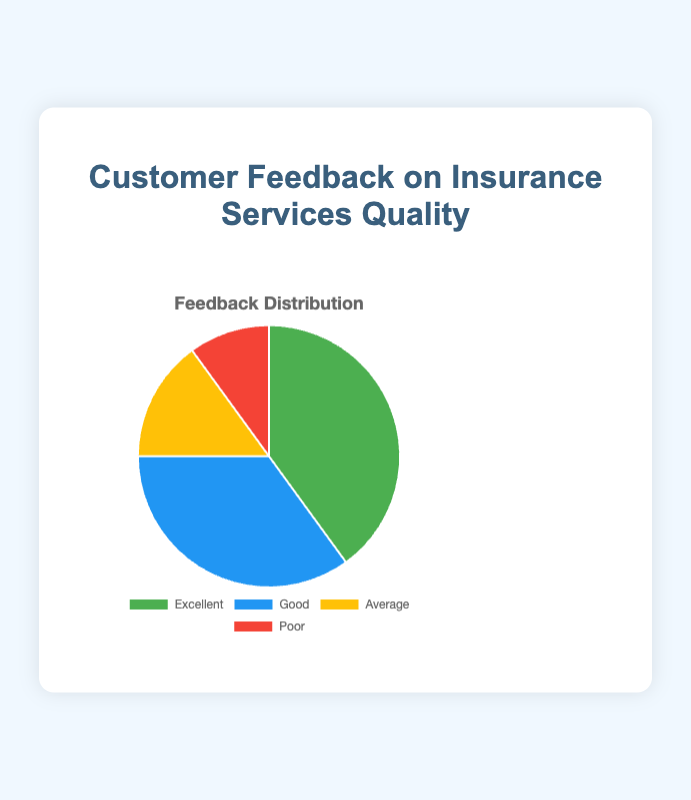What percentage of the feedback is categorized as Good? The pie chart shows different feedback categories along with their respective percentages. By looking at the 'Good' category, we can see it represents 35% of the total feedback.
Answer: 35% Which feedback category has the highest percentage? By evaluating the size of each section in the pie chart and comparing the percentages, we can see that the 'Excellent' category, at 40%, is the largest.
Answer: Excellent What is the sum of the percentages for the 'Average' and 'Poor' feedback categories? To find the sum of the percentages for 'Average' and 'Poor,' we add their values: Average (15%) + Poor (10%) = 15% + 10% = 25%.
Answer: 25% How much higher is the percentage of 'Excellent' feedback compared to 'Average' feedback? We need to subtract the percentage of 'Average' from the percentage of 'Excellent': 40% (Excellent) - 15% (Average) = 25%.
Answer: 25% What is the difference in percentage points between the 'Good' and 'Poor' feedback categories? To determine the difference, subtract the percentage of 'Poor' from 'Good': 35% (Good) - 10% (Poor) = 25%.
Answer: 25% Which feedback category is represented by the smallest section in the pie chart, and what is its percentage? By observing the smallest section in the pie chart, we see that the 'Poor' category is the smallest, comprising 10% of the total feedback.
Answer: Poor What's the combined percentage of the feedback categories rated as Excellent or Good? To find the combined percentage of 'Excellent' and 'Good,' we simply add their percentages: 40% (Excellent) + 35% (Good) = 75%.
Answer: 75% If we were to exclude the 'Excellent' feedback, what would the total percentage be for the remaining categories? The total percentage for 'Excellent' is 40%. To find the total for the remaining categories, subtract 40% from 100%: 100% - 40% = 60%.
Answer: 60% 